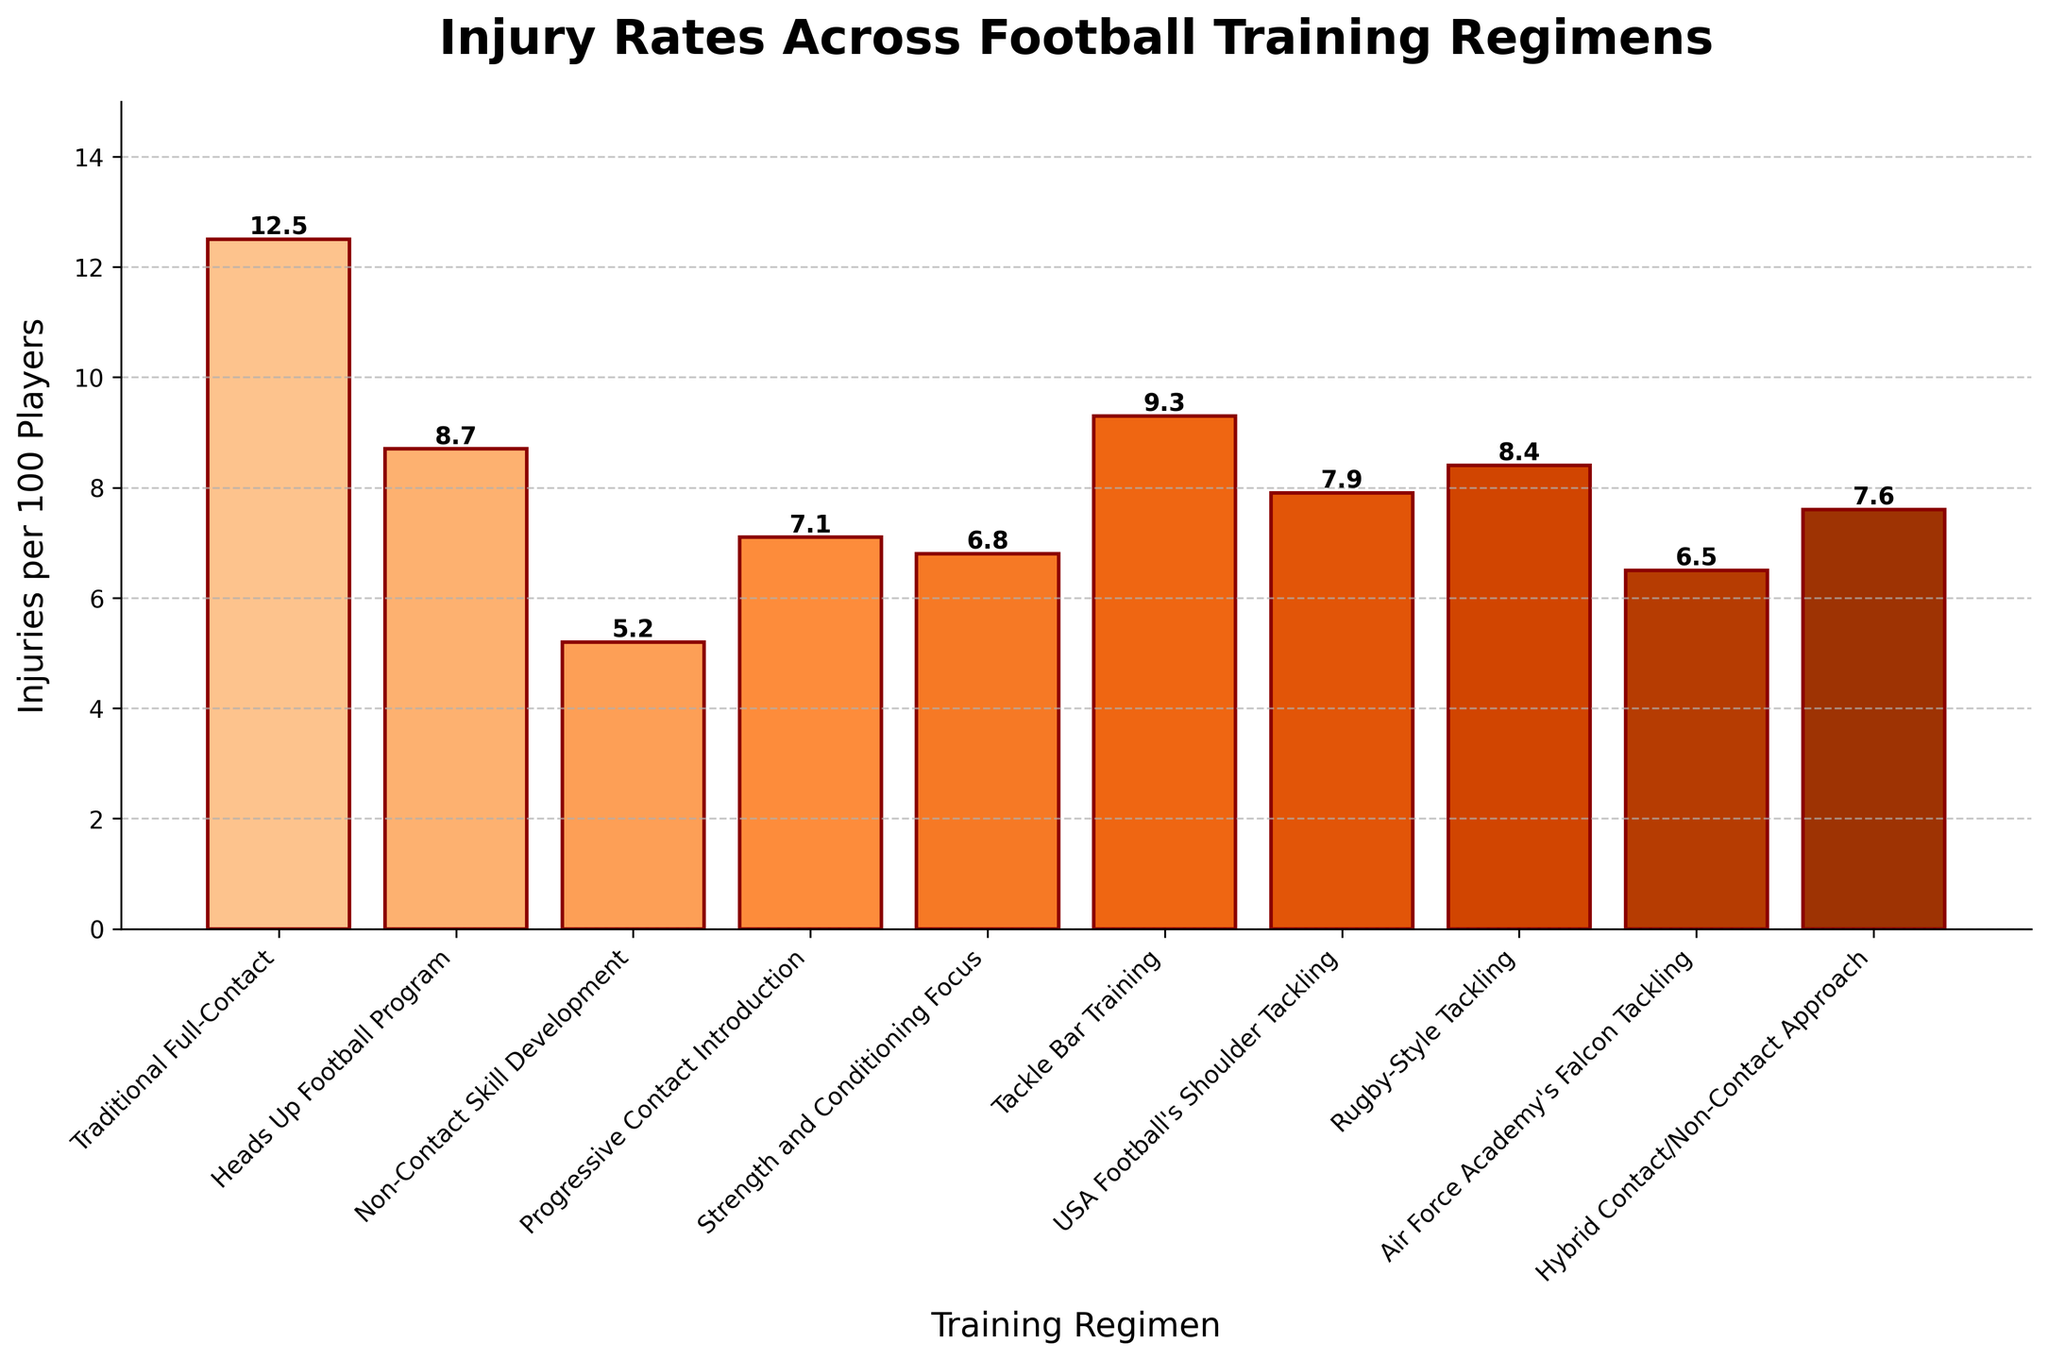Which training regimen has the highest injury rate? Look at the bar chart for the training regimen with the tallest bar. The "Traditional Full-Contact" regimen has the highest bar, indicating it has the highest injury rate.
Answer: Traditional Full-Contact Compare the injury rates of "Traditional Full-Contact" and "Heads Up Football Program." Which one is higher and by how much? First, identify the injury rates for both regimens. "Traditional Full-Contact" has 12.5 injuries per 100 players and "Heads Up Football Program" has 8.7 injuries per 100 players. Subtract the two values: 12.5 - 8.7 = 3.8.
Answer: Traditional Full-Contact by 3.8 What is the average injury rate across all training regimens? Add all the injury rates: 12.5 + 8.7 + 5.2 + 7.1 + 6.8 + 9.3 + 7.9 + 8.4 + 6.5 + 7.6 = 80. Adding the rates, you get a total of 80 injuries per 100 players. There are 10 regimens, so divide 80 by 10: 80 / 10 = 8.0.
Answer: 8.0 Which regimen has the lowest injury rate? By examining the bar chart, look for the shortest bar. The "Non-Contact Skill Development" regimen has the shortest bar, indicating it has the lowest injury rate.
Answer: Non-Contact Skill Development Which regimens have an injury rate lower than 7.0 per 100 players? Identify bars with a height less than 7.0. "Non-Contact Skill Development" (5.2), "Strength and Conditioning Focus" (6.8), and "Air Force Academy's Falcon Tackling" (6.5) meet this criterion.
Answer: Non-Contact Skill Development, Strength and Conditioning Focus, Air Force Academy's Falcon Tackling How many training regimens have an injury rate of more than 8.0 per 100 players? By counting the bars taller than 8.0, we find the following regimens: "Traditional Full-Contact" (12.5), "Heads Up Football Program" (8.7), "Tackle Bar Training" (9.3), "Rugby-Style Tackling" (8.4). So, the answer is four.
Answer: 4 Calculate the difference between the highest and lowest injury rates among the regimens. The highest rate is 12.5 (Traditional Full-Contact) and the lowest is 5.2 (Non-Contact Skill Development). Subtract these values: 12.5 - 5.2 = 7.3.
Answer: 7.3 Is the injury rate for "Rugby-Style Tackling" closer to the highest or lowest injury rate? The highest injury rate is 12.5 (Traditional Full-Contact) and the lowest is 5.2 (Non-Contact Skill Development). The injury rate for "Rugby-Style Tackling" is 8.4. Calculate the differences: 12.5 - 8.4 = 4.1 and 8.4 - 5.2 = 3.2. Since 3.2 is smaller than 4.1, "Rugby-Style Tackling" is closer to the lowest injury rate.
Answer: Closest to lowest Which regimen is just below "Tackle Bar Training" in injury rate? Identify the value for "Tackle Bar Training" (9.3), and find the regimen immediately lower. "Heads Up Football Program" at 8.7 is the next lower value.
Answer: Heads Up Football Program What is the range of injury rates for all the regimens presented? The range is calculated by subtracting the lowest value from the highest value. The highest injury rate is 12.5, and the lowest is 5.2. Subtract these values: 12.5 - 5.2 = 7.3.
Answer: 7.3 